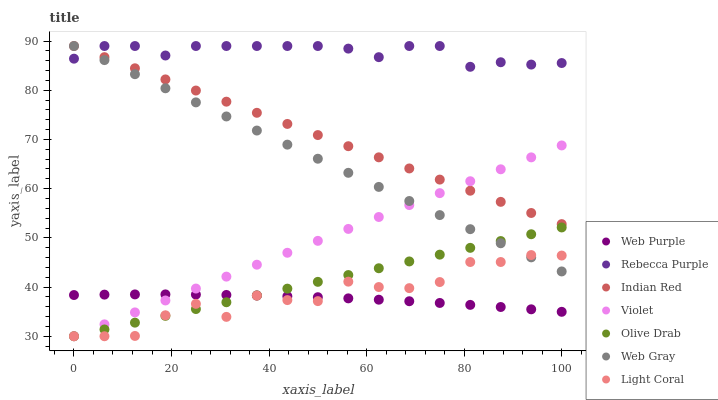Does Web Purple have the minimum area under the curve?
Answer yes or no. Yes. Does Rebecca Purple have the maximum area under the curve?
Answer yes or no. Yes. Does Light Coral have the minimum area under the curve?
Answer yes or no. No. Does Light Coral have the maximum area under the curve?
Answer yes or no. No. Is Indian Red the smoothest?
Answer yes or no. Yes. Is Light Coral the roughest?
Answer yes or no. Yes. Is Web Purple the smoothest?
Answer yes or no. No. Is Web Purple the roughest?
Answer yes or no. No. Does Light Coral have the lowest value?
Answer yes or no. Yes. Does Web Purple have the lowest value?
Answer yes or no. No. Does Indian Red have the highest value?
Answer yes or no. Yes. Does Light Coral have the highest value?
Answer yes or no. No. Is Web Purple less than Rebecca Purple?
Answer yes or no. Yes. Is Rebecca Purple greater than Violet?
Answer yes or no. Yes. Does Rebecca Purple intersect Web Gray?
Answer yes or no. Yes. Is Rebecca Purple less than Web Gray?
Answer yes or no. No. Is Rebecca Purple greater than Web Gray?
Answer yes or no. No. Does Web Purple intersect Rebecca Purple?
Answer yes or no. No. 